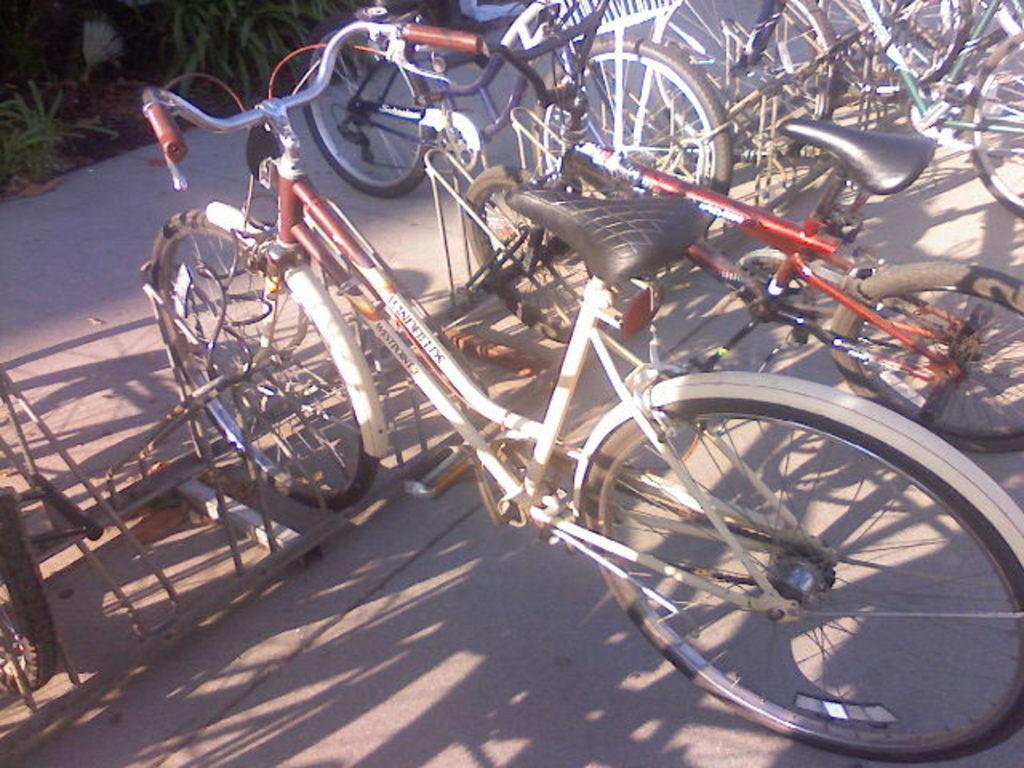In one or two sentences, can you explain what this image depicts? In this image there are a few cycles parked on the road surface, in front of the cycles there are plants. 